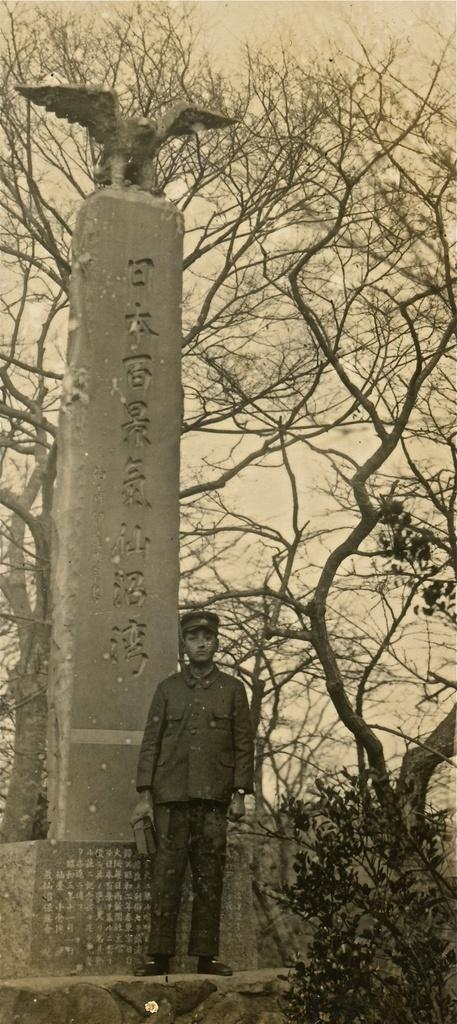What is the color scheme of the image? The image is black and white. What is the main subject in the image? There is a statue in the image. What other elements can be seen in the image besides the statue? There are trees in the image. Where is the tub located in the image? There is no tub present in the image. How many passengers are visible in the image? There are no passengers visible in the image. 